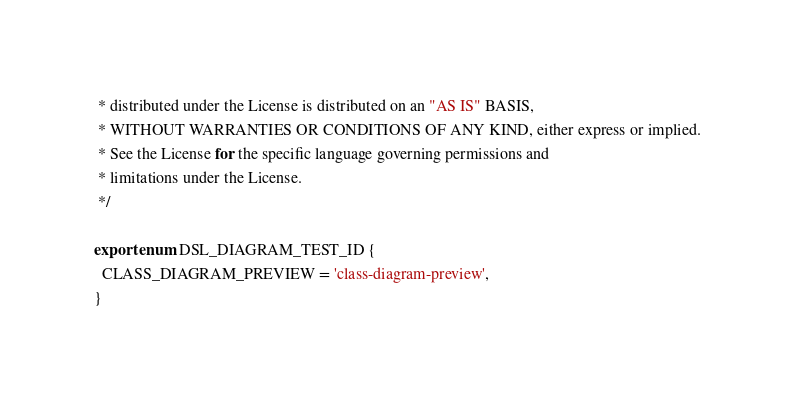<code> <loc_0><loc_0><loc_500><loc_500><_TypeScript_> * distributed under the License is distributed on an "AS IS" BASIS,
 * WITHOUT WARRANTIES OR CONDITIONS OF ANY KIND, either express or implied.
 * See the License for the specific language governing permissions and
 * limitations under the License.
 */

export enum DSL_DIAGRAM_TEST_ID {
  CLASS_DIAGRAM_PREVIEW = 'class-diagram-preview',
}
</code> 